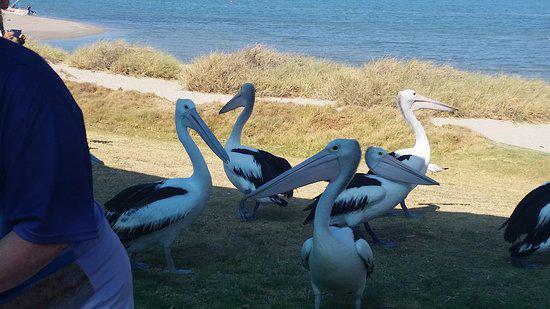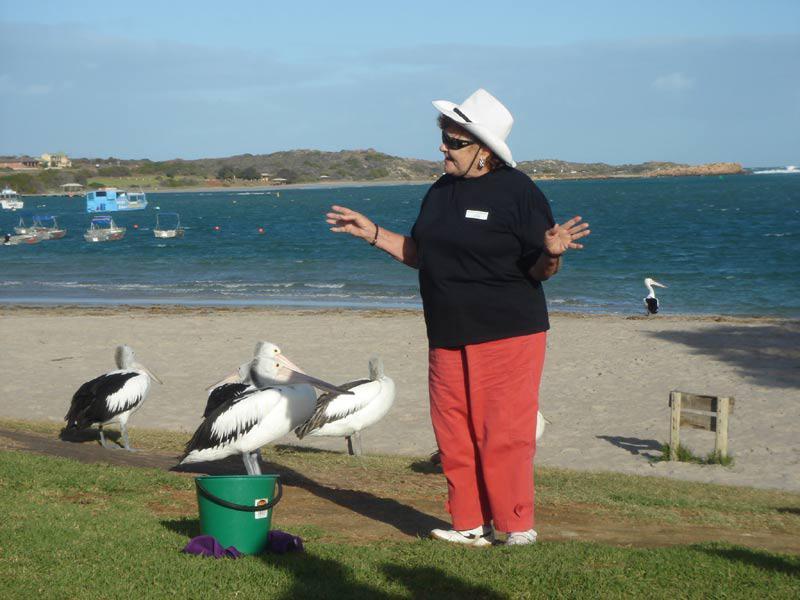The first image is the image on the left, the second image is the image on the right. Given the left and right images, does the statement "In the image on the right, you can see exactly three of the birds, as there are none in the background." hold true? Answer yes or no. No. 